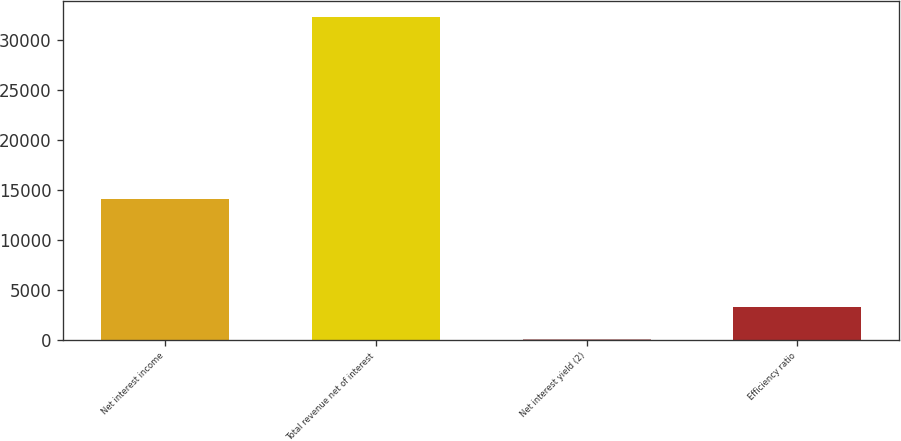Convert chart. <chart><loc_0><loc_0><loc_500><loc_500><bar_chart><fcel>Net interest income<fcel>Total revenue net of interest<fcel>Net interest yield (2)<fcel>Efficiency ratio<nl><fcel>14070<fcel>32290<fcel>2.93<fcel>3231.64<nl></chart> 